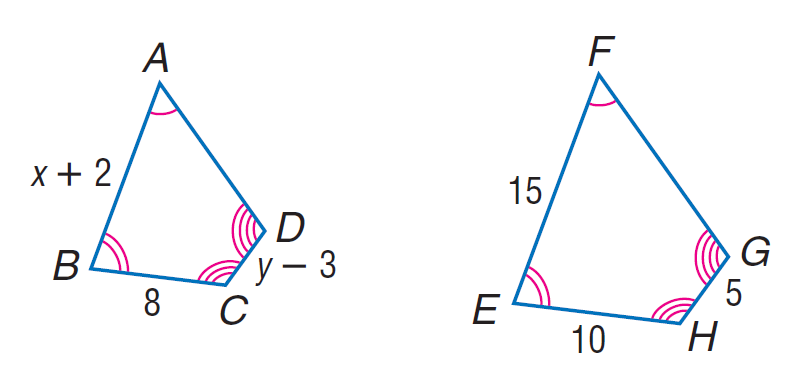Question: Each pair of polygons is similar. Find x.
Choices:
A. 5
B. 8
C. 10
D. 15
Answer with the letter. Answer: C Question: Each pair of polygons is similar. Find y.
Choices:
A. 7
B. 8
C. 10
D. 45
Answer with the letter. Answer: A 